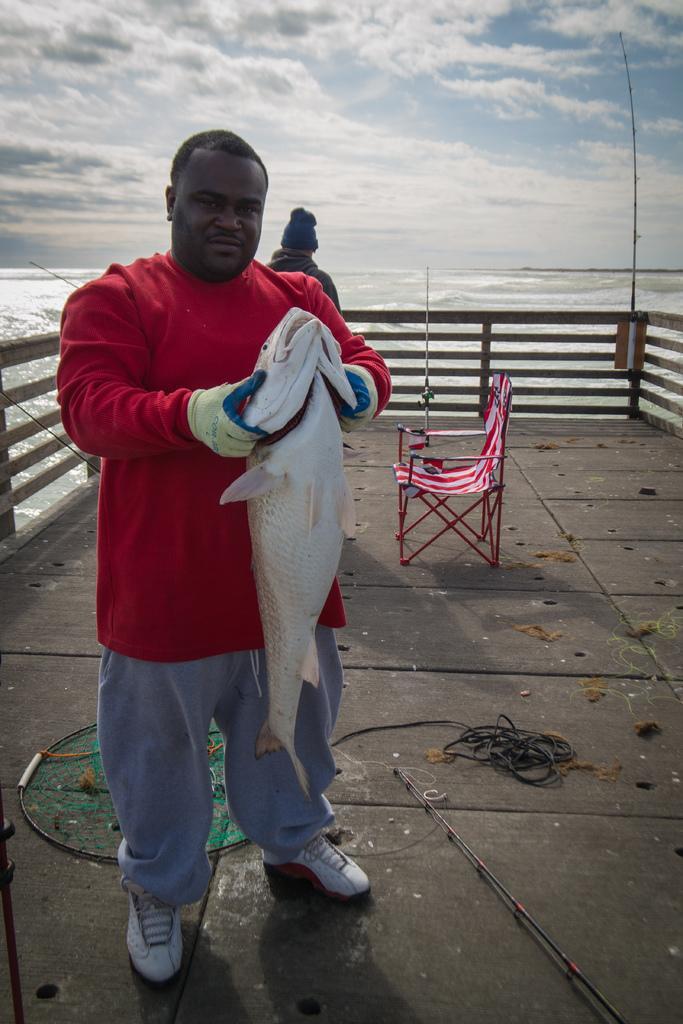Describe this image in one or two sentences. In this image there is a person standing on the floor. He is holding a fish. Behind him there is a net on the floor. Right side there is a chair. Left side there is a person wearing a cap. There is a fence on the floor. Behind there is water. Top of the image there is sky, having clouds. 